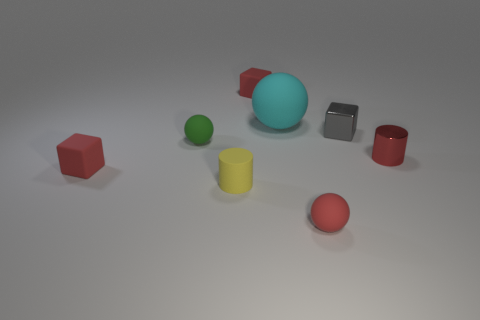What size is the cylinder on the right side of the yellow matte cylinder?
Give a very brief answer. Small. Are there any small blocks of the same color as the large object?
Offer a very short reply. No. Does the big matte object have the same color as the shiny cylinder?
Your answer should be very brief. No. There is a rubber thing that is in front of the tiny yellow cylinder; what number of small red matte things are behind it?
Give a very brief answer. 2. What number of other large objects have the same material as the green thing?
Offer a very short reply. 1. Are there any red objects behind the tiny yellow matte cylinder?
Provide a succinct answer. Yes. There is another matte cylinder that is the same size as the red cylinder; what is its color?
Keep it short and to the point. Yellow. How many things are rubber spheres on the left side of the cyan sphere or cyan metal balls?
Give a very brief answer. 1. What size is the red object that is both to the right of the green rubber sphere and on the left side of the red sphere?
Give a very brief answer. Small. There is a ball that is the same color as the tiny metallic cylinder; what is its size?
Your answer should be compact. Small. 